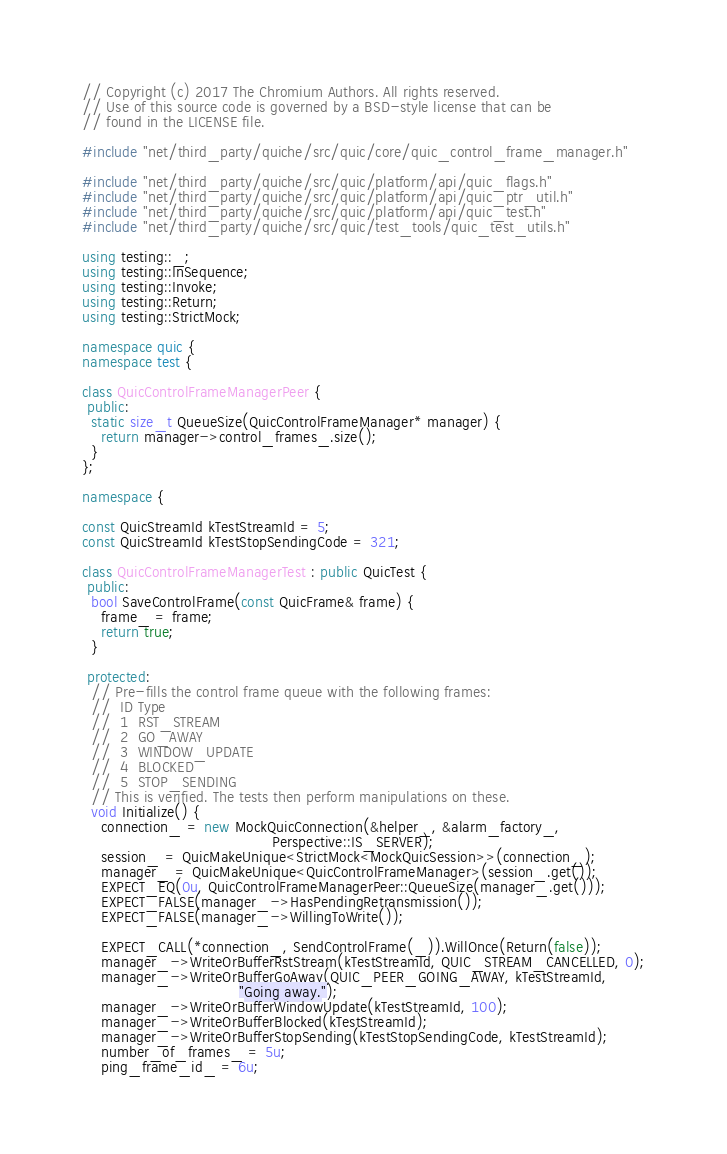Convert code to text. <code><loc_0><loc_0><loc_500><loc_500><_C++_>// Copyright (c) 2017 The Chromium Authors. All rights reserved.
// Use of this source code is governed by a BSD-style license that can be
// found in the LICENSE file.

#include "net/third_party/quiche/src/quic/core/quic_control_frame_manager.h"

#include "net/third_party/quiche/src/quic/platform/api/quic_flags.h"
#include "net/third_party/quiche/src/quic/platform/api/quic_ptr_util.h"
#include "net/third_party/quiche/src/quic/platform/api/quic_test.h"
#include "net/third_party/quiche/src/quic/test_tools/quic_test_utils.h"

using testing::_;
using testing::InSequence;
using testing::Invoke;
using testing::Return;
using testing::StrictMock;

namespace quic {
namespace test {

class QuicControlFrameManagerPeer {
 public:
  static size_t QueueSize(QuicControlFrameManager* manager) {
    return manager->control_frames_.size();
  }
};

namespace {

const QuicStreamId kTestStreamId = 5;
const QuicStreamId kTestStopSendingCode = 321;

class QuicControlFrameManagerTest : public QuicTest {
 public:
  bool SaveControlFrame(const QuicFrame& frame) {
    frame_ = frame;
    return true;
  }

 protected:
  // Pre-fills the control frame queue with the following frames:
  //  ID Type
  //  1  RST_STREAM
  //  2  GO_AWAY
  //  3  WINDOW_UPDATE
  //  4  BLOCKED
  //  5  STOP_SENDING
  // This is verified. The tests then perform manipulations on these.
  void Initialize() {
    connection_ = new MockQuicConnection(&helper_, &alarm_factory_,
                                         Perspective::IS_SERVER);
    session_ = QuicMakeUnique<StrictMock<MockQuicSession>>(connection_);
    manager_ = QuicMakeUnique<QuicControlFrameManager>(session_.get());
    EXPECT_EQ(0u, QuicControlFrameManagerPeer::QueueSize(manager_.get()));
    EXPECT_FALSE(manager_->HasPendingRetransmission());
    EXPECT_FALSE(manager_->WillingToWrite());

    EXPECT_CALL(*connection_, SendControlFrame(_)).WillOnce(Return(false));
    manager_->WriteOrBufferRstStream(kTestStreamId, QUIC_STREAM_CANCELLED, 0);
    manager_->WriteOrBufferGoAway(QUIC_PEER_GOING_AWAY, kTestStreamId,
                                  "Going away.");
    manager_->WriteOrBufferWindowUpdate(kTestStreamId, 100);
    manager_->WriteOrBufferBlocked(kTestStreamId);
    manager_->WriteOrBufferStopSending(kTestStopSendingCode, kTestStreamId);
    number_of_frames_ = 5u;
    ping_frame_id_ = 6u;</code> 